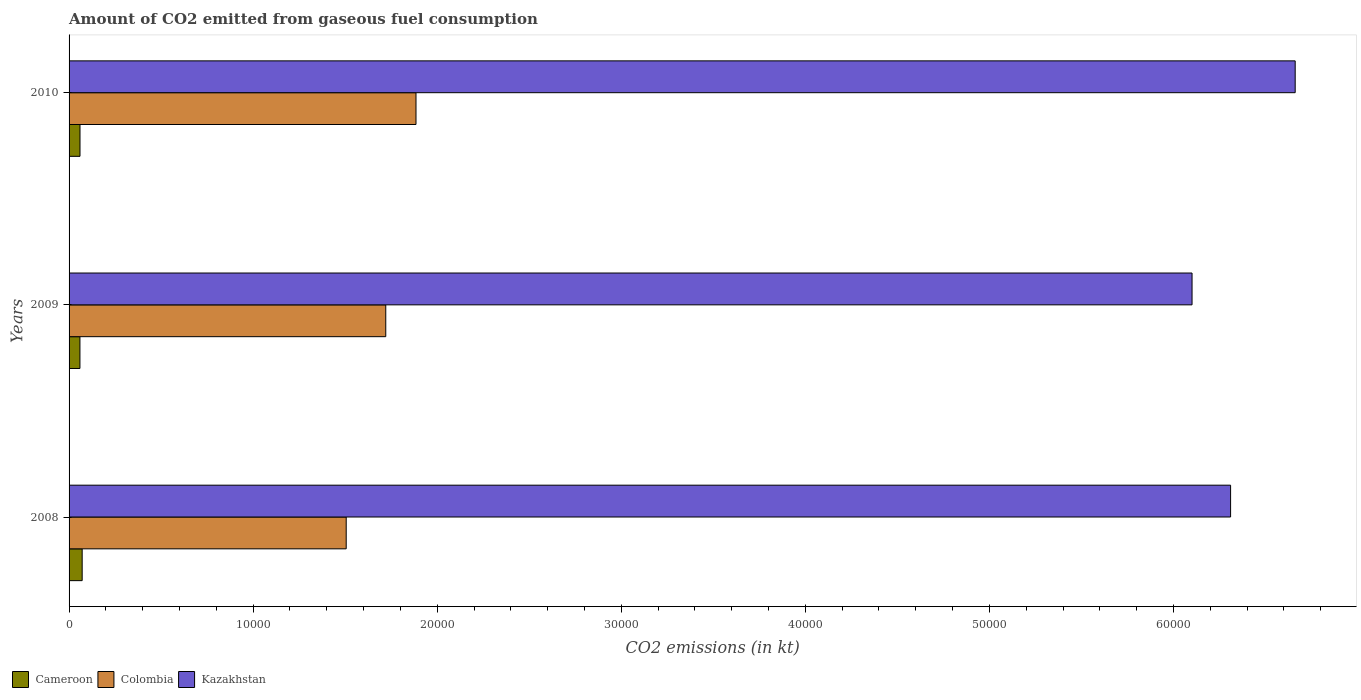How many bars are there on the 3rd tick from the top?
Offer a terse response. 3. What is the amount of CO2 emitted in Cameroon in 2008?
Provide a succinct answer. 711.4. Across all years, what is the maximum amount of CO2 emitted in Colombia?
Offer a terse response. 1.88e+04. Across all years, what is the minimum amount of CO2 emitted in Cameroon?
Your answer should be very brief. 590.39. What is the total amount of CO2 emitted in Cameroon in the graph?
Your answer should be very brief. 1895.84. What is the difference between the amount of CO2 emitted in Cameroon in 2008 and that in 2010?
Your answer should be compact. 117.34. What is the difference between the amount of CO2 emitted in Kazakhstan in 2010 and the amount of CO2 emitted in Cameroon in 2008?
Your answer should be very brief. 6.59e+04. What is the average amount of CO2 emitted in Colombia per year?
Give a very brief answer. 1.70e+04. In the year 2010, what is the difference between the amount of CO2 emitted in Cameroon and amount of CO2 emitted in Colombia?
Provide a succinct answer. -1.83e+04. In how many years, is the amount of CO2 emitted in Colombia greater than 46000 kt?
Provide a succinct answer. 0. What is the ratio of the amount of CO2 emitted in Colombia in 2008 to that in 2009?
Your answer should be compact. 0.88. Is the amount of CO2 emitted in Kazakhstan in 2008 less than that in 2009?
Your response must be concise. No. Is the difference between the amount of CO2 emitted in Cameroon in 2008 and 2010 greater than the difference between the amount of CO2 emitted in Colombia in 2008 and 2010?
Your response must be concise. Yes. What is the difference between the highest and the second highest amount of CO2 emitted in Kazakhstan?
Offer a terse response. 3509.32. What is the difference between the highest and the lowest amount of CO2 emitted in Kazakhstan?
Give a very brief answer. 5603.18. Is the sum of the amount of CO2 emitted in Colombia in 2008 and 2010 greater than the maximum amount of CO2 emitted in Cameroon across all years?
Provide a succinct answer. Yes. What does the 3rd bar from the top in 2009 represents?
Make the answer very short. Cameroon. What does the 1st bar from the bottom in 2010 represents?
Provide a short and direct response. Cameroon. Is it the case that in every year, the sum of the amount of CO2 emitted in Cameroon and amount of CO2 emitted in Colombia is greater than the amount of CO2 emitted in Kazakhstan?
Your answer should be compact. No. Are the values on the major ticks of X-axis written in scientific E-notation?
Offer a terse response. No. Where does the legend appear in the graph?
Offer a very short reply. Bottom left. How many legend labels are there?
Ensure brevity in your answer.  3. What is the title of the graph?
Your response must be concise. Amount of CO2 emitted from gaseous fuel consumption. What is the label or title of the X-axis?
Ensure brevity in your answer.  CO2 emissions (in kt). What is the label or title of the Y-axis?
Your answer should be very brief. Years. What is the CO2 emissions (in kt) of Cameroon in 2008?
Offer a very short reply. 711.4. What is the CO2 emissions (in kt) in Colombia in 2008?
Ensure brevity in your answer.  1.51e+04. What is the CO2 emissions (in kt) in Kazakhstan in 2008?
Keep it short and to the point. 6.31e+04. What is the CO2 emissions (in kt) in Cameroon in 2009?
Make the answer very short. 590.39. What is the CO2 emissions (in kt) in Colombia in 2009?
Your answer should be compact. 1.72e+04. What is the CO2 emissions (in kt) in Kazakhstan in 2009?
Provide a short and direct response. 6.10e+04. What is the CO2 emissions (in kt) of Cameroon in 2010?
Make the answer very short. 594.05. What is the CO2 emissions (in kt) in Colombia in 2010?
Ensure brevity in your answer.  1.88e+04. What is the CO2 emissions (in kt) in Kazakhstan in 2010?
Your response must be concise. 6.66e+04. Across all years, what is the maximum CO2 emissions (in kt) of Cameroon?
Your answer should be compact. 711.4. Across all years, what is the maximum CO2 emissions (in kt) of Colombia?
Make the answer very short. 1.88e+04. Across all years, what is the maximum CO2 emissions (in kt) of Kazakhstan?
Provide a succinct answer. 6.66e+04. Across all years, what is the minimum CO2 emissions (in kt) in Cameroon?
Your response must be concise. 590.39. Across all years, what is the minimum CO2 emissions (in kt) in Colombia?
Your response must be concise. 1.51e+04. Across all years, what is the minimum CO2 emissions (in kt) in Kazakhstan?
Provide a short and direct response. 6.10e+04. What is the total CO2 emissions (in kt) in Cameroon in the graph?
Offer a terse response. 1895.84. What is the total CO2 emissions (in kt) in Colombia in the graph?
Your answer should be compact. 5.11e+04. What is the total CO2 emissions (in kt) in Kazakhstan in the graph?
Your response must be concise. 1.91e+05. What is the difference between the CO2 emissions (in kt) of Cameroon in 2008 and that in 2009?
Your answer should be compact. 121.01. What is the difference between the CO2 emissions (in kt) in Colombia in 2008 and that in 2009?
Ensure brevity in your answer.  -2148.86. What is the difference between the CO2 emissions (in kt) in Kazakhstan in 2008 and that in 2009?
Provide a short and direct response. 2093.86. What is the difference between the CO2 emissions (in kt) in Cameroon in 2008 and that in 2010?
Offer a terse response. 117.34. What is the difference between the CO2 emissions (in kt) of Colombia in 2008 and that in 2010?
Keep it short and to the point. -3791.68. What is the difference between the CO2 emissions (in kt) of Kazakhstan in 2008 and that in 2010?
Ensure brevity in your answer.  -3509.32. What is the difference between the CO2 emissions (in kt) in Cameroon in 2009 and that in 2010?
Provide a short and direct response. -3.67. What is the difference between the CO2 emissions (in kt) in Colombia in 2009 and that in 2010?
Offer a terse response. -1642.82. What is the difference between the CO2 emissions (in kt) of Kazakhstan in 2009 and that in 2010?
Make the answer very short. -5603.18. What is the difference between the CO2 emissions (in kt) in Cameroon in 2008 and the CO2 emissions (in kt) in Colombia in 2009?
Give a very brief answer. -1.65e+04. What is the difference between the CO2 emissions (in kt) of Cameroon in 2008 and the CO2 emissions (in kt) of Kazakhstan in 2009?
Offer a very short reply. -6.03e+04. What is the difference between the CO2 emissions (in kt) of Colombia in 2008 and the CO2 emissions (in kt) of Kazakhstan in 2009?
Offer a terse response. -4.60e+04. What is the difference between the CO2 emissions (in kt) of Cameroon in 2008 and the CO2 emissions (in kt) of Colombia in 2010?
Your response must be concise. -1.81e+04. What is the difference between the CO2 emissions (in kt) of Cameroon in 2008 and the CO2 emissions (in kt) of Kazakhstan in 2010?
Give a very brief answer. -6.59e+04. What is the difference between the CO2 emissions (in kt) in Colombia in 2008 and the CO2 emissions (in kt) in Kazakhstan in 2010?
Your answer should be compact. -5.16e+04. What is the difference between the CO2 emissions (in kt) of Cameroon in 2009 and the CO2 emissions (in kt) of Colombia in 2010?
Ensure brevity in your answer.  -1.83e+04. What is the difference between the CO2 emissions (in kt) of Cameroon in 2009 and the CO2 emissions (in kt) of Kazakhstan in 2010?
Your answer should be compact. -6.60e+04. What is the difference between the CO2 emissions (in kt) in Colombia in 2009 and the CO2 emissions (in kt) in Kazakhstan in 2010?
Your answer should be very brief. -4.94e+04. What is the average CO2 emissions (in kt) in Cameroon per year?
Your answer should be very brief. 631.95. What is the average CO2 emissions (in kt) of Colombia per year?
Provide a succinct answer. 1.70e+04. What is the average CO2 emissions (in kt) in Kazakhstan per year?
Offer a very short reply. 6.36e+04. In the year 2008, what is the difference between the CO2 emissions (in kt) of Cameroon and CO2 emissions (in kt) of Colombia?
Keep it short and to the point. -1.43e+04. In the year 2008, what is the difference between the CO2 emissions (in kt) of Cameroon and CO2 emissions (in kt) of Kazakhstan?
Your answer should be compact. -6.24e+04. In the year 2008, what is the difference between the CO2 emissions (in kt) of Colombia and CO2 emissions (in kt) of Kazakhstan?
Offer a terse response. -4.80e+04. In the year 2009, what is the difference between the CO2 emissions (in kt) of Cameroon and CO2 emissions (in kt) of Colombia?
Make the answer very short. -1.66e+04. In the year 2009, what is the difference between the CO2 emissions (in kt) of Cameroon and CO2 emissions (in kt) of Kazakhstan?
Provide a succinct answer. -6.04e+04. In the year 2009, what is the difference between the CO2 emissions (in kt) in Colombia and CO2 emissions (in kt) in Kazakhstan?
Provide a succinct answer. -4.38e+04. In the year 2010, what is the difference between the CO2 emissions (in kt) in Cameroon and CO2 emissions (in kt) in Colombia?
Keep it short and to the point. -1.83e+04. In the year 2010, what is the difference between the CO2 emissions (in kt) of Cameroon and CO2 emissions (in kt) of Kazakhstan?
Give a very brief answer. -6.60e+04. In the year 2010, what is the difference between the CO2 emissions (in kt) of Colombia and CO2 emissions (in kt) of Kazakhstan?
Ensure brevity in your answer.  -4.78e+04. What is the ratio of the CO2 emissions (in kt) of Cameroon in 2008 to that in 2009?
Your response must be concise. 1.21. What is the ratio of the CO2 emissions (in kt) of Colombia in 2008 to that in 2009?
Your answer should be compact. 0.88. What is the ratio of the CO2 emissions (in kt) of Kazakhstan in 2008 to that in 2009?
Make the answer very short. 1.03. What is the ratio of the CO2 emissions (in kt) of Cameroon in 2008 to that in 2010?
Provide a succinct answer. 1.2. What is the ratio of the CO2 emissions (in kt) of Colombia in 2008 to that in 2010?
Provide a succinct answer. 0.8. What is the ratio of the CO2 emissions (in kt) of Kazakhstan in 2008 to that in 2010?
Provide a succinct answer. 0.95. What is the ratio of the CO2 emissions (in kt) in Colombia in 2009 to that in 2010?
Your answer should be very brief. 0.91. What is the ratio of the CO2 emissions (in kt) of Kazakhstan in 2009 to that in 2010?
Make the answer very short. 0.92. What is the difference between the highest and the second highest CO2 emissions (in kt) in Cameroon?
Offer a very short reply. 117.34. What is the difference between the highest and the second highest CO2 emissions (in kt) in Colombia?
Provide a succinct answer. 1642.82. What is the difference between the highest and the second highest CO2 emissions (in kt) of Kazakhstan?
Ensure brevity in your answer.  3509.32. What is the difference between the highest and the lowest CO2 emissions (in kt) of Cameroon?
Your response must be concise. 121.01. What is the difference between the highest and the lowest CO2 emissions (in kt) in Colombia?
Provide a succinct answer. 3791.68. What is the difference between the highest and the lowest CO2 emissions (in kt) in Kazakhstan?
Your response must be concise. 5603.18. 